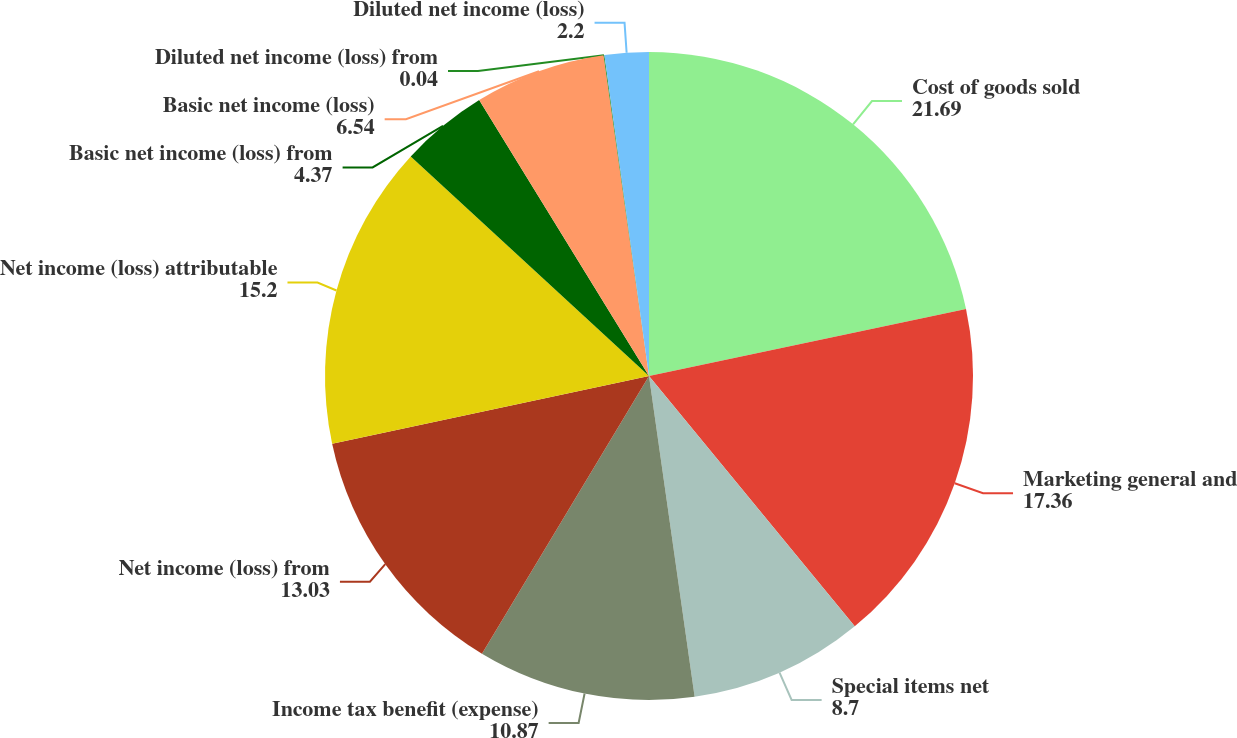<chart> <loc_0><loc_0><loc_500><loc_500><pie_chart><fcel>Cost of goods sold<fcel>Marketing general and<fcel>Special items net<fcel>Income tax benefit (expense)<fcel>Net income (loss) from<fcel>Net income (loss) attributable<fcel>Basic net income (loss) from<fcel>Basic net income (loss)<fcel>Diluted net income (loss) from<fcel>Diluted net income (loss)<nl><fcel>21.69%<fcel>17.36%<fcel>8.7%<fcel>10.87%<fcel>13.03%<fcel>15.2%<fcel>4.37%<fcel>6.54%<fcel>0.04%<fcel>2.2%<nl></chart> 